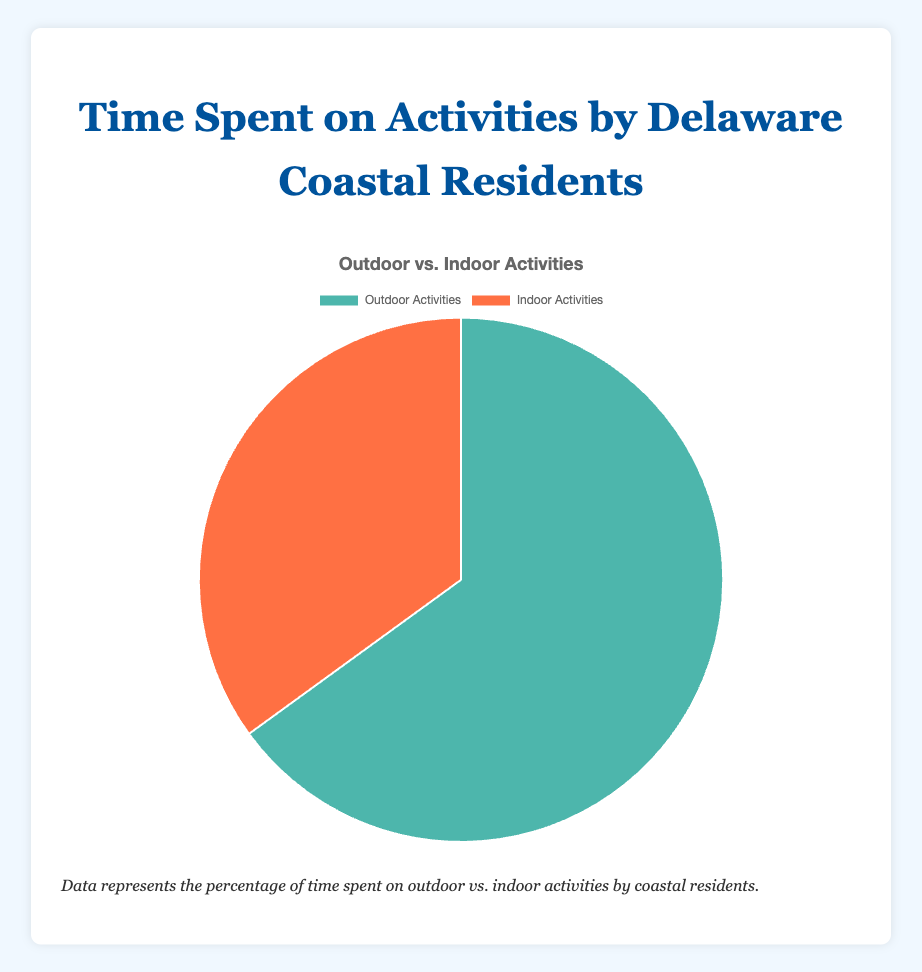What's the total percentage of time spent on Beach Visits and Museum Visits? Beach Visits account for 35% of Outdoor Activities (which is 65% of total time), so 65% * 35% = 22.75%. Museum Visits account for 15% of Indoor Activities (which is 35% of total time), so 35% * 15% = 5.25%. Adding them gives us 22.75% + 5.25% = 28%.
Answer: 28% Which activity category has a higher percentage of time spent according to the chart, Outdoor Activities or Indoor Activities? Outdoor Activities have a percentage of 65%, whereas Indoor Activities have a percentage of 35%. Therefore, Outdoor Activities have a higher percentage.
Answer: Outdoor Activities How much more time do Delaware coastal residents spend on Outdoor Activities compared to Indoor Activities? The percentage of Outdoor Activities is 65%, and the percentage of Indoor Activities is 35%. The difference between these two percentages is 65% - 35% = 30%.
Answer: 30% What is the proportion of time spent on Local Theater Shows compared to total time spent on Indoor Activities? Local Theater Shows have a frequency of 10% within the Indoor Activities, which constitutes 10% of the 35% allocated to Indoor Activities. Therefore, the proportion is (10% of 35%) or 3.5%.
Answer: 3.5% What is the color used to represent Indoor Activities in the pie chart? In the chart, Indoor Activities are represented with an orange color.
Answer: Orange Is the percentage of time spent on Hiking in State Parks higher or lower than the percentage of time spent on Fishing? The time spent on Hiking in State Parks is 20%, whereas the time spent on Fishing is 10%. Therefore, Hiking in State Parks has a higher percentage.
Answer: Higher Compare the frequencies of Beach Visits and Hiking in State Parks together versus the total percentage time spent on Indoor Activities. Which one is higher? Beach Visits have a frequency of 35% and Hiking in State Parks have 20%. Together, they make 35% + 20% = 55%. The total percentage time spent on Indoor Activities is 35%. Therefore, 55% is higher than 35%.
Answer: 55% What's the average percentage of time spent on activities within Indoor Activities? The percentages of individual activities within Indoor Activities are 15% (Museum Visits), 10% (Local Theater Shows), and 10% (Indoor Sports). The average is (15% + 10% + 10%) / 3 = 35% / 3 ≈ 11.67%.
Answer: 11.67% What is the activity with the least frequency within the Indoor Activities category? Both Local Theater Shows and Indoor Sports share the lowest frequency within the Indoor Activities category, each at 10%.
Answer: Local Theater Shows and Indoor Sports If Delaware coastal residents equally redistributed 10% of their time from Outdoor Activities to Indoor Activities, what would the new percentage allocations be? Currently, Outdoor Activities are 65% and Indoor Activities are 35%. If 10% of the time is shifted from Outdoor to Indoor, Outdoor would become 65% - 10% = 55% and Indoor would become 35% + 10% = 45%.
Answer: Outdoor: 55%, Indoor: 45% 